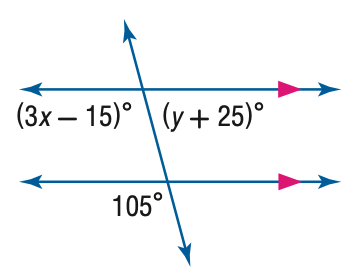Answer the mathemtical geometry problem and directly provide the correct option letter.
Question: Find the value of the variable x in the figure.
Choices: A: 30 B: 40 C: 50 D: 60 B 